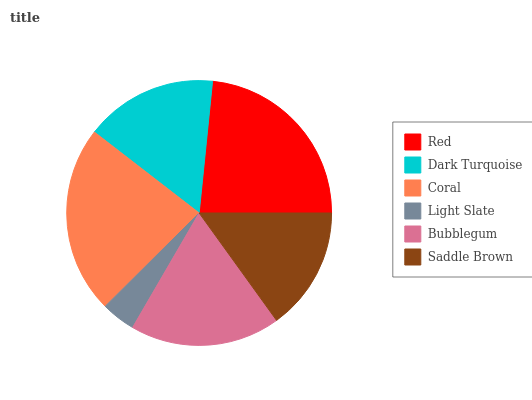Is Light Slate the minimum?
Answer yes or no. Yes. Is Red the maximum?
Answer yes or no. Yes. Is Dark Turquoise the minimum?
Answer yes or no. No. Is Dark Turquoise the maximum?
Answer yes or no. No. Is Red greater than Dark Turquoise?
Answer yes or no. Yes. Is Dark Turquoise less than Red?
Answer yes or no. Yes. Is Dark Turquoise greater than Red?
Answer yes or no. No. Is Red less than Dark Turquoise?
Answer yes or no. No. Is Bubblegum the high median?
Answer yes or no. Yes. Is Dark Turquoise the low median?
Answer yes or no. Yes. Is Saddle Brown the high median?
Answer yes or no. No. Is Saddle Brown the low median?
Answer yes or no. No. 